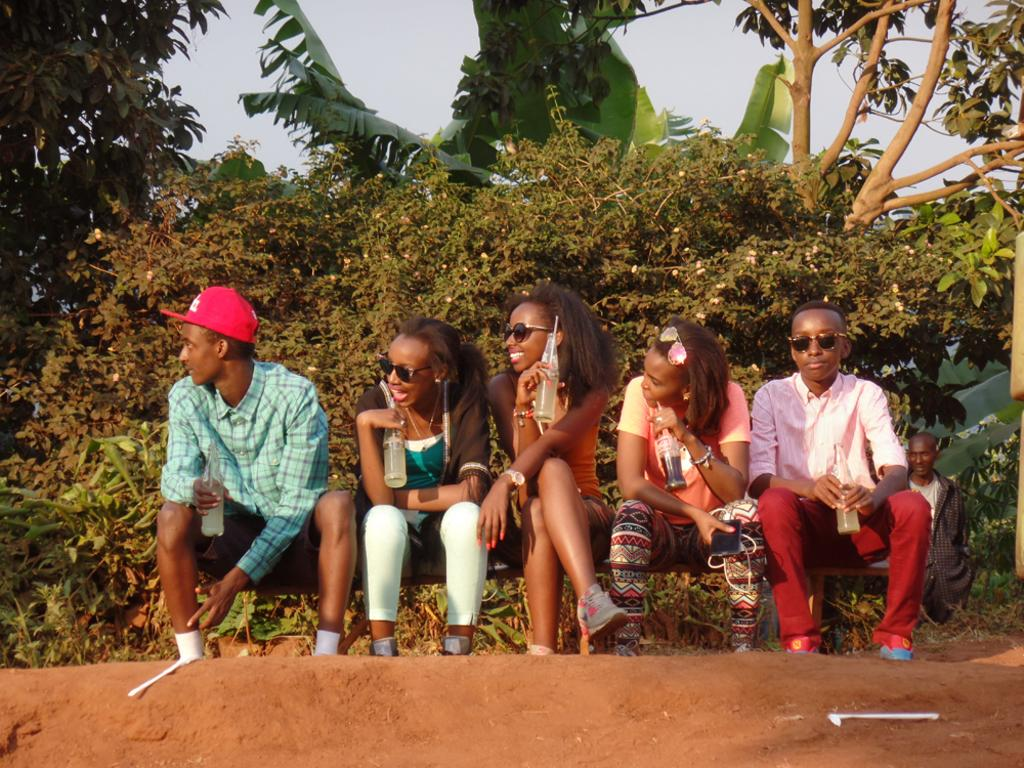What are the persons in the image doing? There is a group of persons sitting on the surface, and they are holding bottles in their hands. Can you describe the person in the background of the image? There is a person standing in the background of the image. What can be seen in the background of the image besides the person? There is a group of trees and the sky visible in the background of the image. Can you tell me how many goldfish are swimming in the bottles held by the persons in the image? There are no goldfish present in the image; the persons are holding bottles, but there is no indication of what is inside them. What type of drug can be seen being consumed by the persons in the image? There is no drug present in the image; the persons are holding bottles, but there is no indication of what is inside them or whether they are consuming anything. 